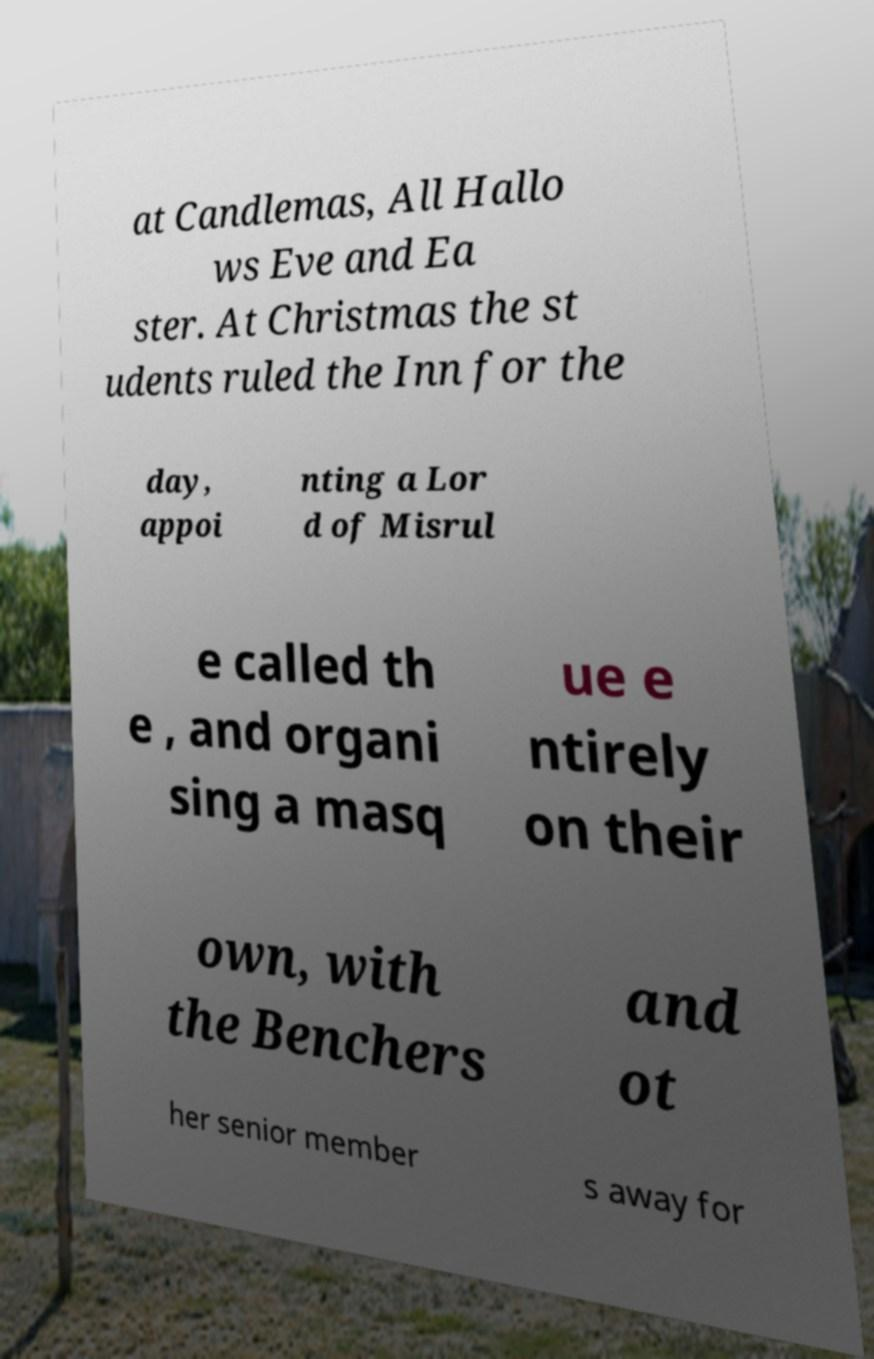What messages or text are displayed in this image? I need them in a readable, typed format. at Candlemas, All Hallo ws Eve and Ea ster. At Christmas the st udents ruled the Inn for the day, appoi nting a Lor d of Misrul e called th e , and organi sing a masq ue e ntirely on their own, with the Benchers and ot her senior member s away for 